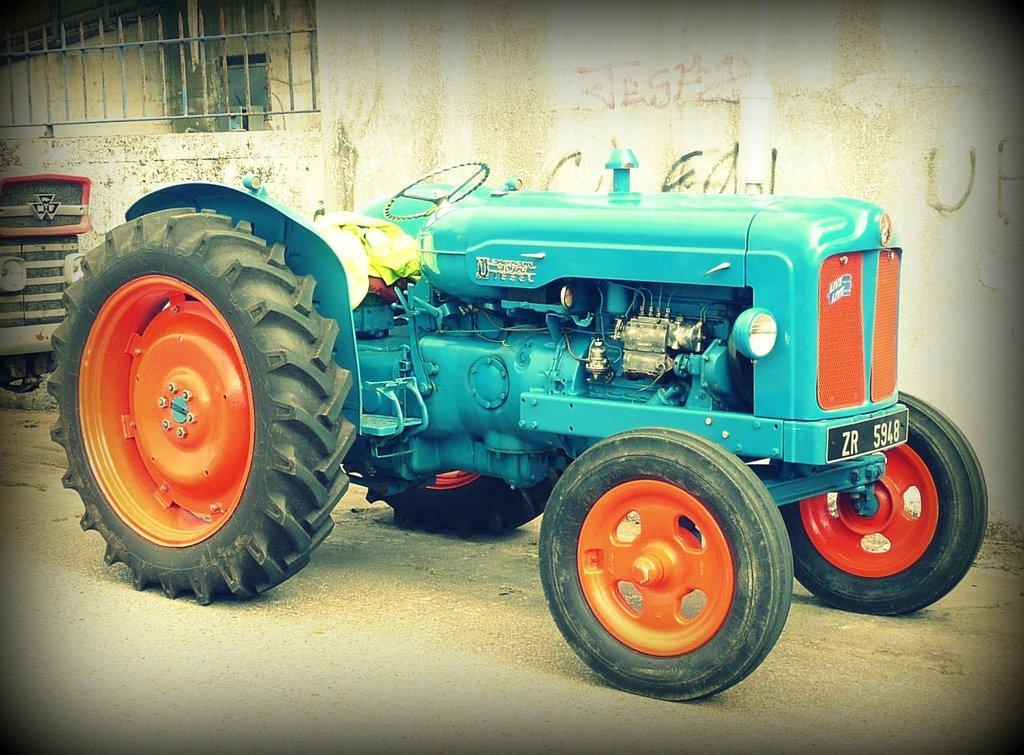How would you summarize this image in a sentence or two? In this image we can see tractor on the road. In the background we can see the front part of a vehicle, texts written on the wall, fence and other objects. 